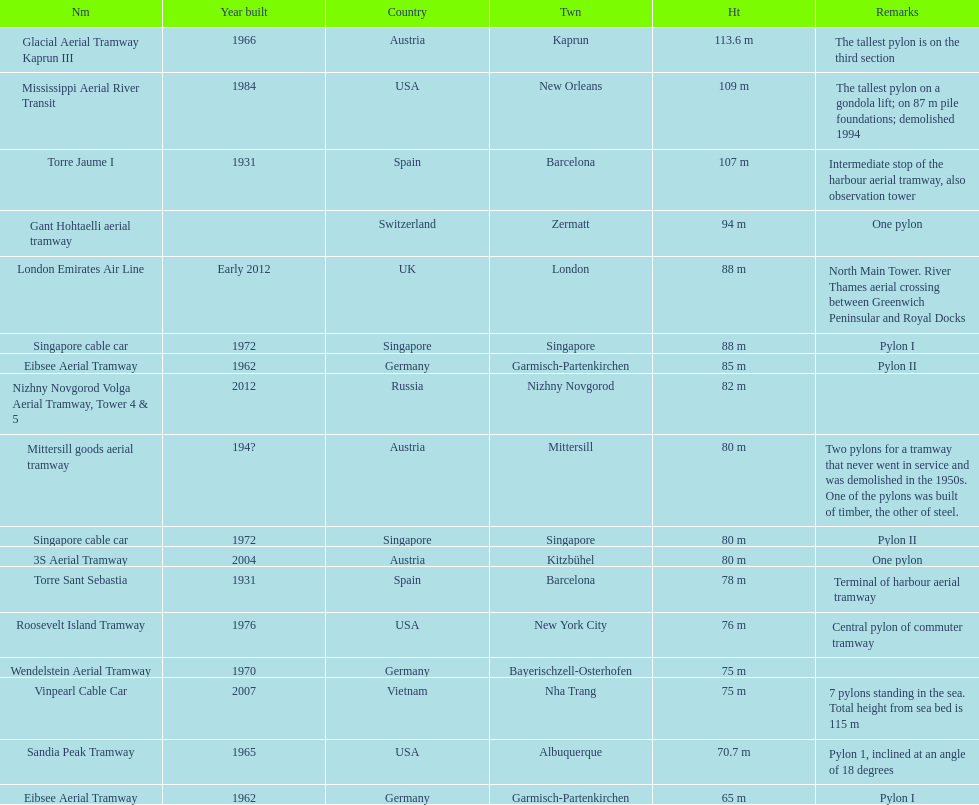What is the total number of tallest pylons in austria? 3. 